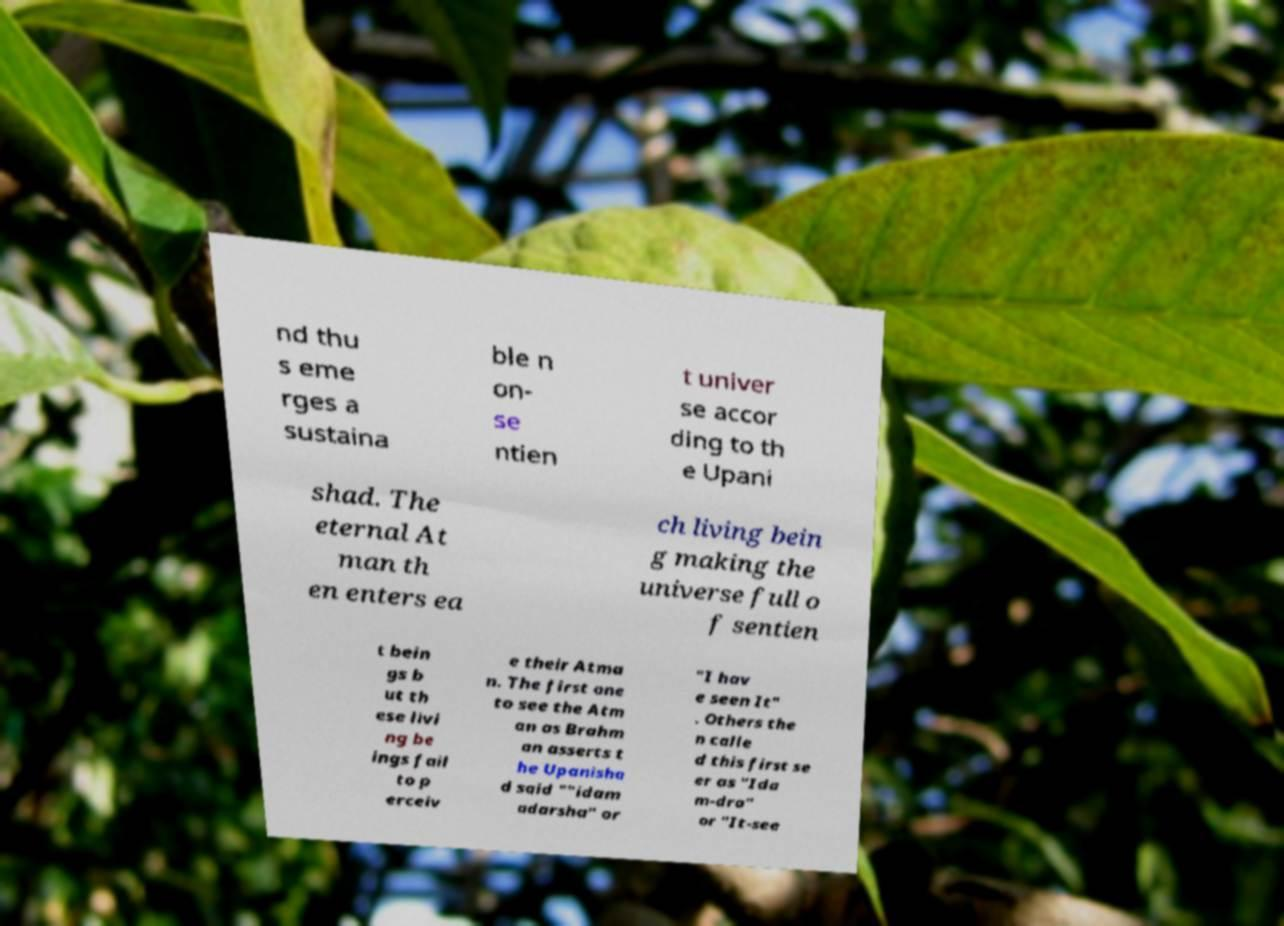Could you assist in decoding the text presented in this image and type it out clearly? nd thu s eme rges a sustaina ble n on- se ntien t univer se accor ding to th e Upani shad. The eternal At man th en enters ea ch living bein g making the universe full o f sentien t bein gs b ut th ese livi ng be ings fail to p erceiv e their Atma n. The first one to see the Atm an as Brahm an asserts t he Upanisha d said ""idam adarsha" or "I hav e seen It" . Others the n calle d this first se er as "Ida m-dra" or "It-see 